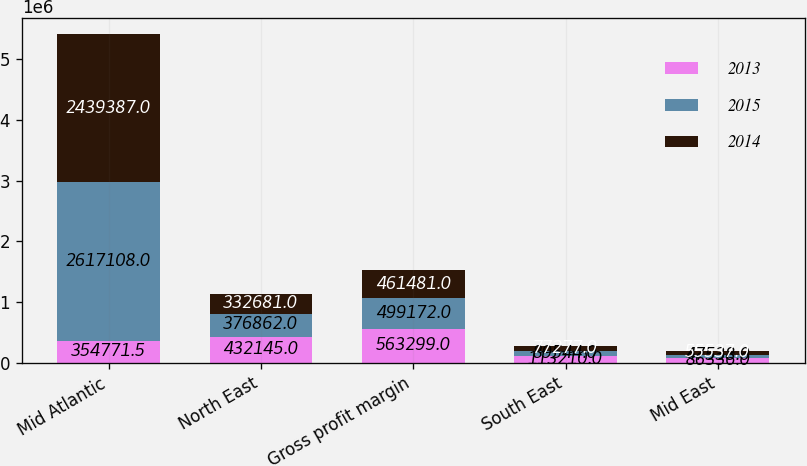Convert chart to OTSL. <chart><loc_0><loc_0><loc_500><loc_500><stacked_bar_chart><ecel><fcel>Mid Atlantic<fcel>North East<fcel>Gross profit margin<fcel>South East<fcel>Mid East<nl><fcel>2013<fcel>354772<fcel>432145<fcel>563299<fcel>113210<fcel>86336<nl><fcel>2015<fcel>2.61711e+06<fcel>376862<fcel>499172<fcel>89544<fcel>47538<nl><fcel>2014<fcel>2.43939e+06<fcel>332681<fcel>461481<fcel>77277<fcel>55537<nl></chart> 